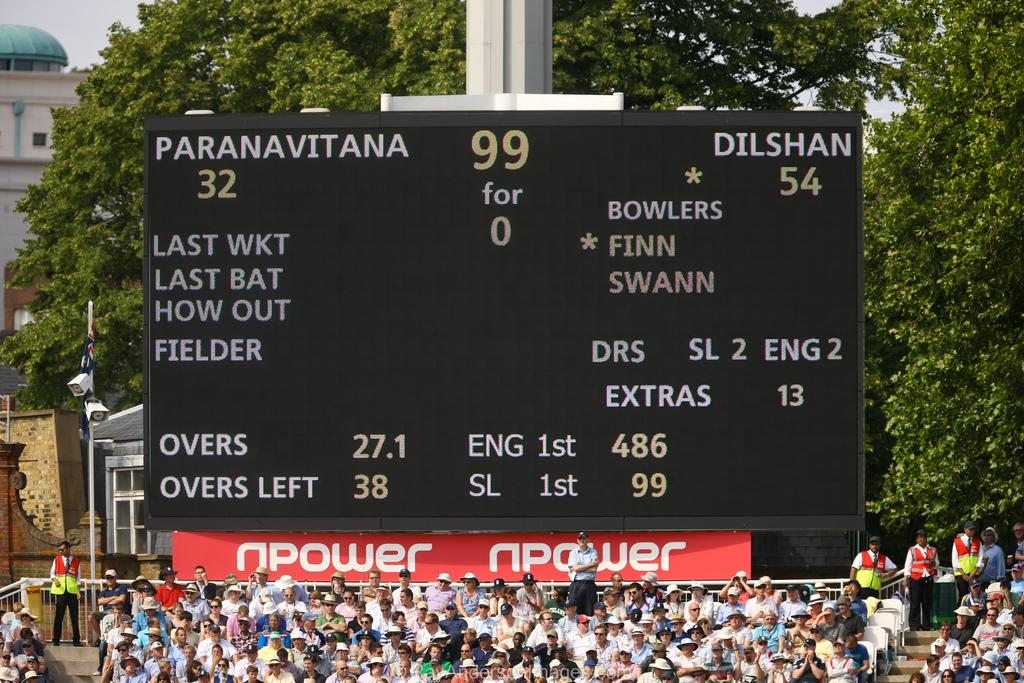<image>
Give a short and clear explanation of the subsequent image. A scoreboard for the teams Paranavitana versing the Dilshan in a stadium with an audience of fans 